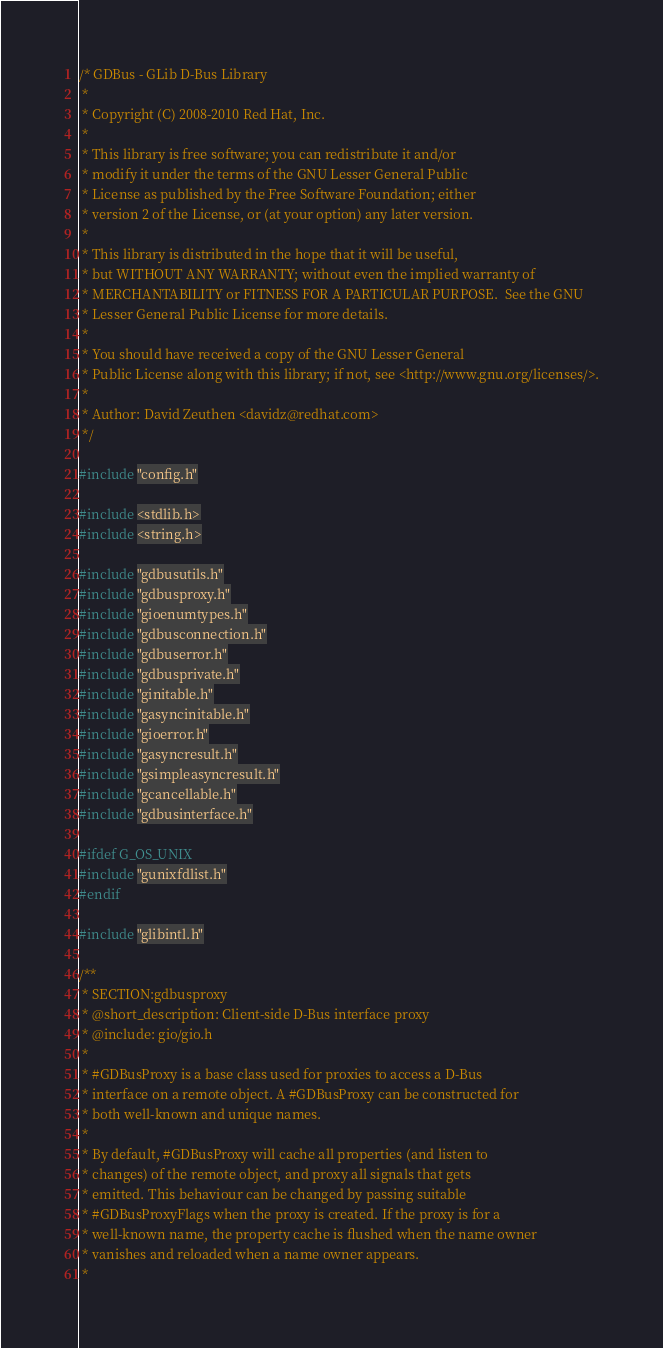Convert code to text. <code><loc_0><loc_0><loc_500><loc_500><_C_>/* GDBus - GLib D-Bus Library
 *
 * Copyright (C) 2008-2010 Red Hat, Inc.
 *
 * This library is free software; you can redistribute it and/or
 * modify it under the terms of the GNU Lesser General Public
 * License as published by the Free Software Foundation; either
 * version 2 of the License, or (at your option) any later version.
 *
 * This library is distributed in the hope that it will be useful,
 * but WITHOUT ANY WARRANTY; without even the implied warranty of
 * MERCHANTABILITY or FITNESS FOR A PARTICULAR PURPOSE.  See the GNU
 * Lesser General Public License for more details.
 *
 * You should have received a copy of the GNU Lesser General
 * Public License along with this library; if not, see <http://www.gnu.org/licenses/>.
 *
 * Author: David Zeuthen <davidz@redhat.com>
 */

#include "config.h"

#include <stdlib.h>
#include <string.h>

#include "gdbusutils.h"
#include "gdbusproxy.h"
#include "gioenumtypes.h"
#include "gdbusconnection.h"
#include "gdbuserror.h"
#include "gdbusprivate.h"
#include "ginitable.h"
#include "gasyncinitable.h"
#include "gioerror.h"
#include "gasyncresult.h"
#include "gsimpleasyncresult.h"
#include "gcancellable.h"
#include "gdbusinterface.h"

#ifdef G_OS_UNIX
#include "gunixfdlist.h"
#endif

#include "glibintl.h"

/**
 * SECTION:gdbusproxy
 * @short_description: Client-side D-Bus interface proxy
 * @include: gio/gio.h
 *
 * #GDBusProxy is a base class used for proxies to access a D-Bus
 * interface on a remote object. A #GDBusProxy can be constructed for
 * both well-known and unique names.
 *
 * By default, #GDBusProxy will cache all properties (and listen to
 * changes) of the remote object, and proxy all signals that gets
 * emitted. This behaviour can be changed by passing suitable
 * #GDBusProxyFlags when the proxy is created. If the proxy is for a
 * well-known name, the property cache is flushed when the name owner
 * vanishes and reloaded when a name owner appears.
 *</code> 